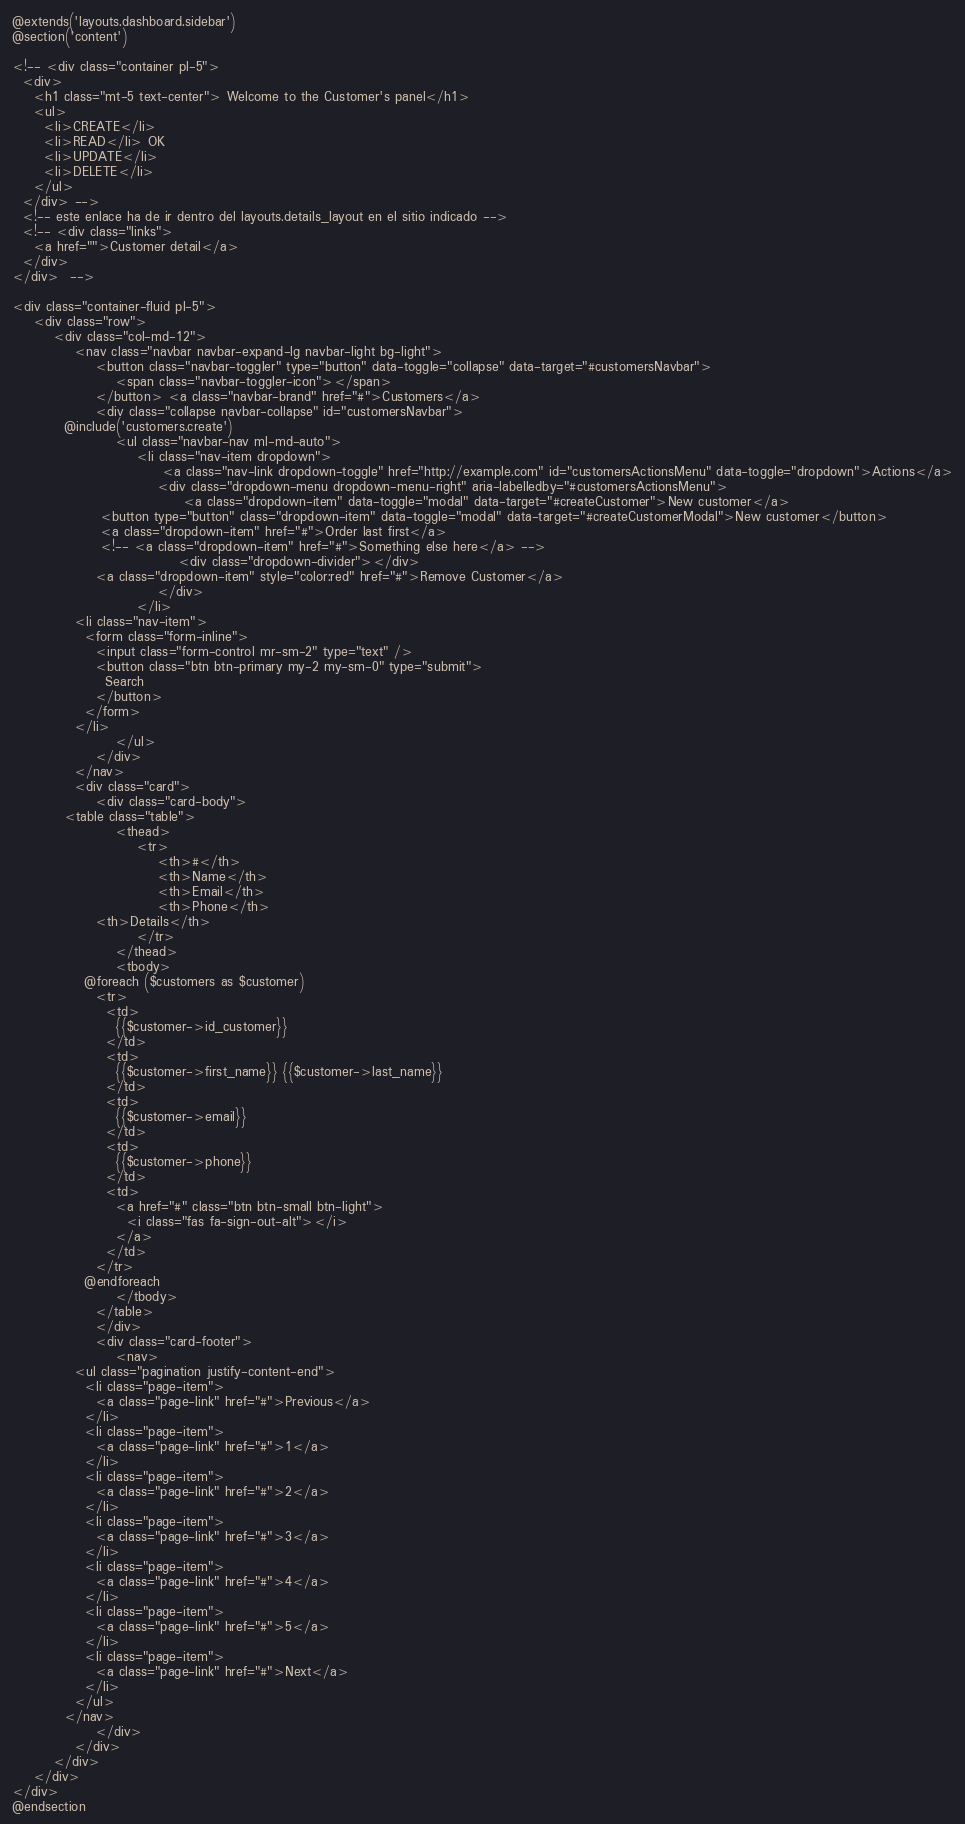<code> <loc_0><loc_0><loc_500><loc_500><_PHP_>@extends('layouts.dashboard.sidebar')
@section('content')

<!-- <div class="container pl-5">
  <div>
    <h1 class="mt-5 text-center"> Welcome to the Customer's panel</h1>
    <ul>
      <li>CREATE</li>
      <li>READ</li> OK
      <li>UPDATE</li>
      <li>DELETE</li>
    </ul>
  </div> -->
  <!-- este enlace ha de ir dentro del layouts.details_layout en el sitio indicado -->
  <!-- <div class="links">
    <a href="">Customer detail</a>
  </div>
</div>  -->

<div class="container-fluid pl-5">
	<div class="row">
		<div class="col-md-12">
			<nav class="navbar navbar-expand-lg navbar-light bg-light">
				<button class="navbar-toggler" type="button" data-toggle="collapse" data-target="#customersNavbar">
					<span class="navbar-toggler-icon"></span>
				</button> <a class="navbar-brand" href="#">Customers</a>
				<div class="collapse navbar-collapse" id="customersNavbar">
          @include('customers.create')
					<ul class="navbar-nav ml-md-auto">
						<li class="nav-item dropdown">
							 <a class="nav-link dropdown-toggle" href="http://example.com" id="customersActionsMenu" data-toggle="dropdown">Actions</a>
							<div class="dropdown-menu dropdown-menu-right" aria-labelledby="#customersActionsMenu">
								 <a class="dropdown-item" data-toggle="modal" data-target="#createCustomer">New customer</a>
                 <button type="button" class="dropdown-item" data-toggle="modal" data-target="#createCustomerModal">New customer</button>
                 <a class="dropdown-item" href="#">Order last first</a>
                 <!-- <a class="dropdown-item" href="#">Something else here</a> -->
								<div class="dropdown-divider"></div>
                <a class="dropdown-item" style="color:red" href="#">Remove Customer</a>
							</div>
						</li>
            <li class="nav-item">
              <form class="form-inline">
                <input class="form-control mr-sm-2" type="text" />
                <button class="btn btn-primary my-2 my-sm-0" type="submit">
                  Search
                </button>
              </form>
            </li>
					</ul>
				</div>
			</nav>
			<div class="card">
				<div class="card-body">
          <table class="table">
    				<thead>
    					<tr>
    						<th>#</th>
    						<th>Name</th>
    						<th>Email</th>
    						<th>Phone</th>
                <th>Details</th>
    					</tr>
    				</thead>
    				<tbody>
              @foreach ($customers as $customer)
                <tr>
                  <td>
                    {{$customer->id_customer}}
                  </td>
                  <td>
                    {{$customer->first_name}} {{$customer->last_name}}
                  </td>
                  <td>
                    {{$customer->email}}
                  </td>
                  <td>
                    {{$customer->phone}}
                  </td>
                  <td>
                    <a href="#" class="btn btn-small btn-light">
                      <i class="fas fa-sign-out-alt"></i>
                    </a>
                  </td>
                </tr>
              @endforeach
    				</tbody>
    			</table>
				</div>
				<div class="card-footer">
					<nav>
            <ul class="pagination justify-content-end">
              <li class="page-item">
                <a class="page-link" href="#">Previous</a>
              </li>
              <li class="page-item">
                <a class="page-link" href="#">1</a>
              </li>
              <li class="page-item">
                <a class="page-link" href="#">2</a>
              </li>
              <li class="page-item">
                <a class="page-link" href="#">3</a>
              </li>
              <li class="page-item">
                <a class="page-link" href="#">4</a>
              </li>
              <li class="page-item">
                <a class="page-link" href="#">5</a>
              </li>
              <li class="page-item">
                <a class="page-link" href="#">Next</a>
              </li>
            </ul>
          </nav>
				</div>
			</div>
		</div>
	</div>
</div>
@endsection
</code> 